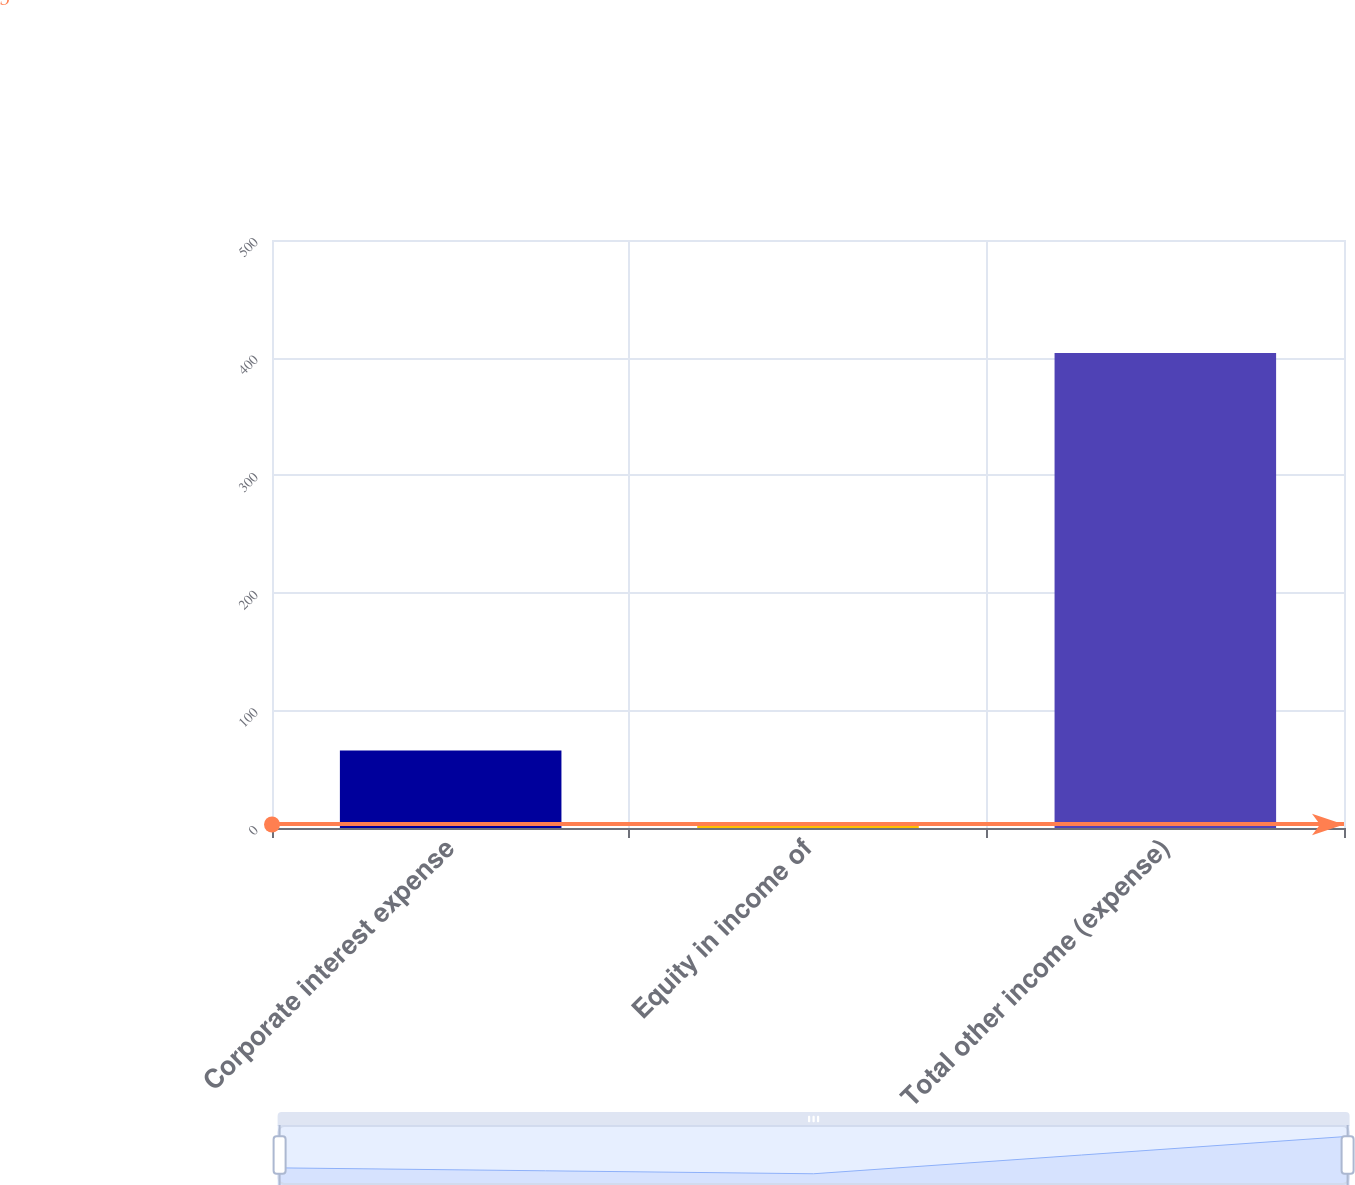Convert chart to OTSL. <chart><loc_0><loc_0><loc_500><loc_500><bar_chart><fcel>Corporate interest expense<fcel>Equity in income of<fcel>Total other income (expense)<nl><fcel>66<fcel>3<fcel>404<nl></chart> 